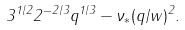<formula> <loc_0><loc_0><loc_500><loc_500>3 ^ { 1 / 2 } 2 ^ { - 2 / 3 } q ^ { 1 / 3 } - \nu _ { * } ( q / w ) ^ { 2 } .</formula> 